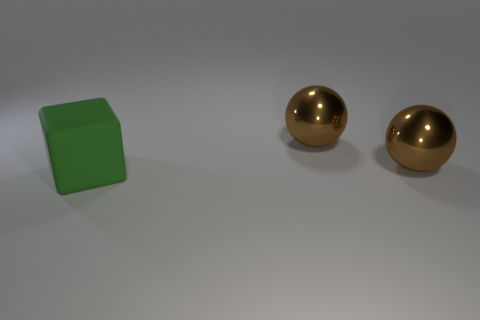How many cubes are either brown objects or rubber things?
Make the answer very short. 1. Are there fewer brown metal objects that are right of the green thing than tiny shiny spheres?
Keep it short and to the point. No. Are there any big green blocks behind the green matte object?
Offer a terse response. No. Is there another big thing of the same shape as the big green matte object?
Keep it short and to the point. No. What number of objects are either things on the right side of the large matte object or large matte blocks?
Provide a short and direct response. 3. Is there a brown metal object that has the same size as the matte cube?
Provide a short and direct response. Yes. The green matte thing is what size?
Ensure brevity in your answer.  Large. What number of other objects are there of the same material as the green block?
Your response must be concise. 0. Is there anything else that is the same shape as the big green rubber thing?
Give a very brief answer. No. Are there fewer things than big rubber blocks?
Give a very brief answer. No. 